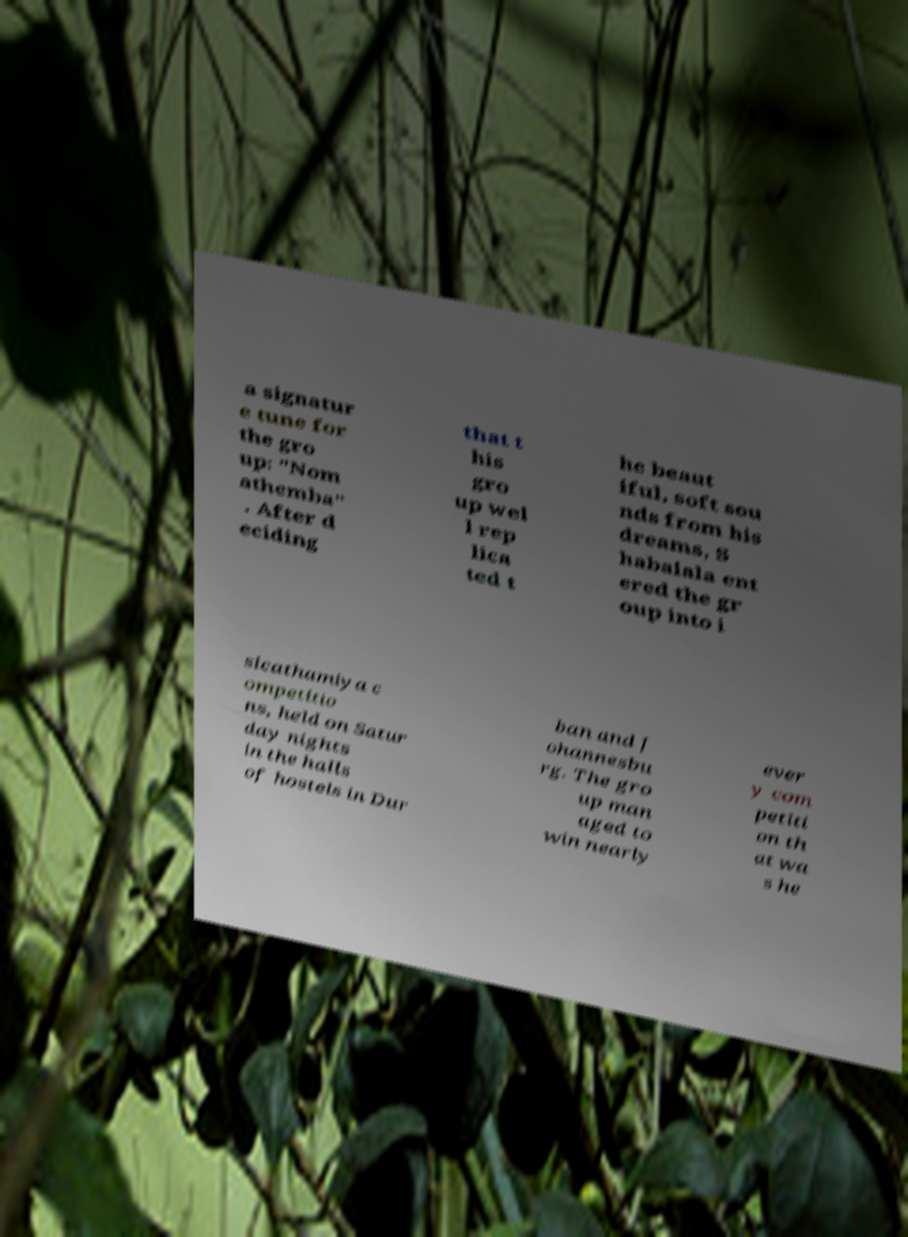Please read and relay the text visible in this image. What does it say? a signatur e tune for the gro up: "Nom athemba" . After d eciding that t his gro up wel l rep lica ted t he beaut iful, soft sou nds from his dreams, S habalala ent ered the gr oup into i sicathamiya c ompetitio ns, held on Satur day nights in the halls of hostels in Dur ban and J ohannesbu rg. The gro up man aged to win nearly ever y com petiti on th at wa s he 